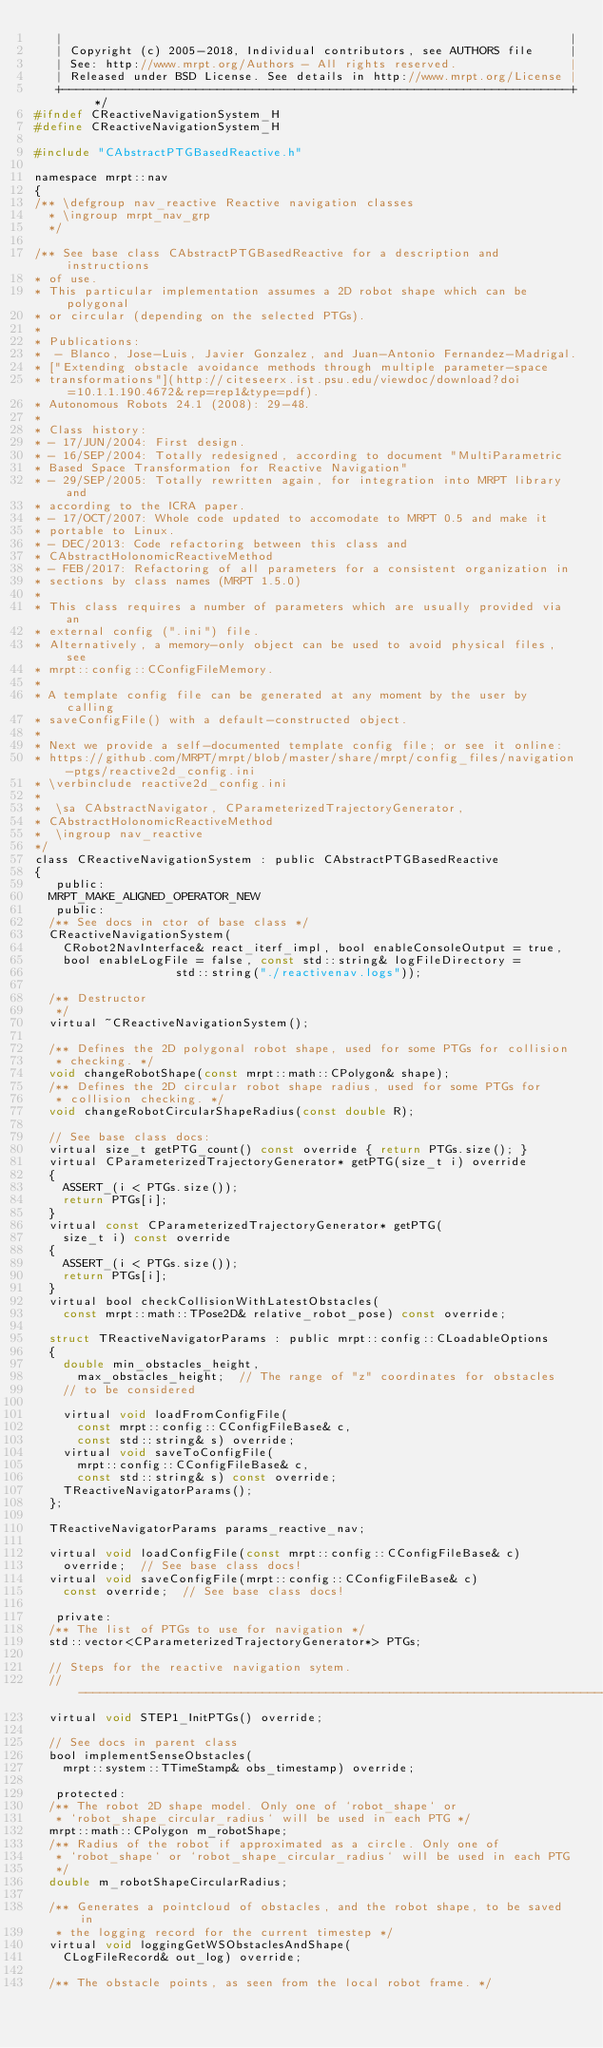<code> <loc_0><loc_0><loc_500><loc_500><_C_>   |                                                                        |
   | Copyright (c) 2005-2018, Individual contributors, see AUTHORS file     |
   | See: http://www.mrpt.org/Authors - All rights reserved.                |
   | Released under BSD License. See details in http://www.mrpt.org/License |
   +------------------------------------------------------------------------+ */
#ifndef CReactiveNavigationSystem_H
#define CReactiveNavigationSystem_H

#include "CAbstractPTGBasedReactive.h"

namespace mrpt::nav
{
/** \defgroup nav_reactive Reactive navigation classes
  * \ingroup mrpt_nav_grp
  */

/** See base class CAbstractPTGBasedReactive for a description and instructions
* of use.
* This particular implementation assumes a 2D robot shape which can be polygonal
* or circular (depending on the selected PTGs).
*
* Publications:
*  - Blanco, Jose-Luis, Javier Gonzalez, and Juan-Antonio Fernandez-Madrigal.
* ["Extending obstacle avoidance methods through multiple parameter-space
* transformations"](http://citeseerx.ist.psu.edu/viewdoc/download?doi=10.1.1.190.4672&rep=rep1&type=pdf).
* Autonomous Robots 24.1 (2008): 29-48.
*
* Class history:
* - 17/JUN/2004: First design.
* - 16/SEP/2004: Totally redesigned, according to document "MultiParametric
* Based Space Transformation for Reactive Navigation"
* - 29/SEP/2005: Totally rewritten again, for integration into MRPT library and
* according to the ICRA paper.
* - 17/OCT/2007: Whole code updated to accomodate to MRPT 0.5 and make it
* portable to Linux.
* - DEC/2013: Code refactoring between this class and
* CAbstractHolonomicReactiveMethod
* - FEB/2017: Refactoring of all parameters for a consistent organization in
* sections by class names (MRPT 1.5.0)
*
* This class requires a number of parameters which are usually provided via an
* external config (".ini") file.
* Alternatively, a memory-only object can be used to avoid physical files, see
* mrpt::config::CConfigFileMemory.
*
* A template config file can be generated at any moment by the user by calling
* saveConfigFile() with a default-constructed object.
*
* Next we provide a self-documented template config file; or see it online:
* https://github.com/MRPT/mrpt/blob/master/share/mrpt/config_files/navigation-ptgs/reactive2d_config.ini
* \verbinclude reactive2d_config.ini
*
*  \sa CAbstractNavigator, CParameterizedTrajectoryGenerator,
* CAbstractHolonomicReactiveMethod
*  \ingroup nav_reactive
*/
class CReactiveNavigationSystem : public CAbstractPTGBasedReactive
{
   public:
	MRPT_MAKE_ALIGNED_OPERATOR_NEW
   public:
	/** See docs in ctor of base class */
	CReactiveNavigationSystem(
		CRobot2NavInterface& react_iterf_impl, bool enableConsoleOutput = true,
		bool enableLogFile = false, const std::string& logFileDirectory =
										std::string("./reactivenav.logs"));

	/** Destructor
	 */
	virtual ~CReactiveNavigationSystem();

	/** Defines the 2D polygonal robot shape, used for some PTGs for collision
	 * checking. */
	void changeRobotShape(const mrpt::math::CPolygon& shape);
	/** Defines the 2D circular robot shape radius, used for some PTGs for
	 * collision checking. */
	void changeRobotCircularShapeRadius(const double R);

	// See base class docs:
	virtual size_t getPTG_count() const override { return PTGs.size(); }
	virtual CParameterizedTrajectoryGenerator* getPTG(size_t i) override
	{
		ASSERT_(i < PTGs.size());
		return PTGs[i];
	}
	virtual const CParameterizedTrajectoryGenerator* getPTG(
		size_t i) const override
	{
		ASSERT_(i < PTGs.size());
		return PTGs[i];
	}
	virtual bool checkCollisionWithLatestObstacles(
		const mrpt::math::TPose2D& relative_robot_pose) const override;

	struct TReactiveNavigatorParams : public mrpt::config::CLoadableOptions
	{
		double min_obstacles_height,
			max_obstacles_height;  // The range of "z" coordinates for obstacles
		// to be considered

		virtual void loadFromConfigFile(
			const mrpt::config::CConfigFileBase& c,
			const std::string& s) override;
		virtual void saveToConfigFile(
			mrpt::config::CConfigFileBase& c,
			const std::string& s) const override;
		TReactiveNavigatorParams();
	};

	TReactiveNavigatorParams params_reactive_nav;

	virtual void loadConfigFile(const mrpt::config::CConfigFileBase& c)
		override;  // See base class docs!
	virtual void saveConfigFile(mrpt::config::CConfigFileBase& c)
		const override;  // See base class docs!

   private:
	/** The list of PTGs to use for navigation */
	std::vector<CParameterizedTrajectoryGenerator*> PTGs;

	// Steps for the reactive navigation sytem.
	// ----------------------------------------------------------------------------
	virtual void STEP1_InitPTGs() override;

	// See docs in parent class
	bool implementSenseObstacles(
		mrpt::system::TTimeStamp& obs_timestamp) override;

   protected:
	/** The robot 2D shape model. Only one of `robot_shape` or
	 * `robot_shape_circular_radius` will be used in each PTG */
	mrpt::math::CPolygon m_robotShape;
	/** Radius of the robot if approximated as a circle. Only one of
	 * `robot_shape` or `robot_shape_circular_radius` will be used in each PTG
	 */
	double m_robotShapeCircularRadius;

	/** Generates a pointcloud of obstacles, and the robot shape, to be saved in
	 * the logging record for the current timestep */
	virtual void loggingGetWSObstaclesAndShape(
		CLogFileRecord& out_log) override;

	/** The obstacle points, as seen from the local robot frame. */</code> 